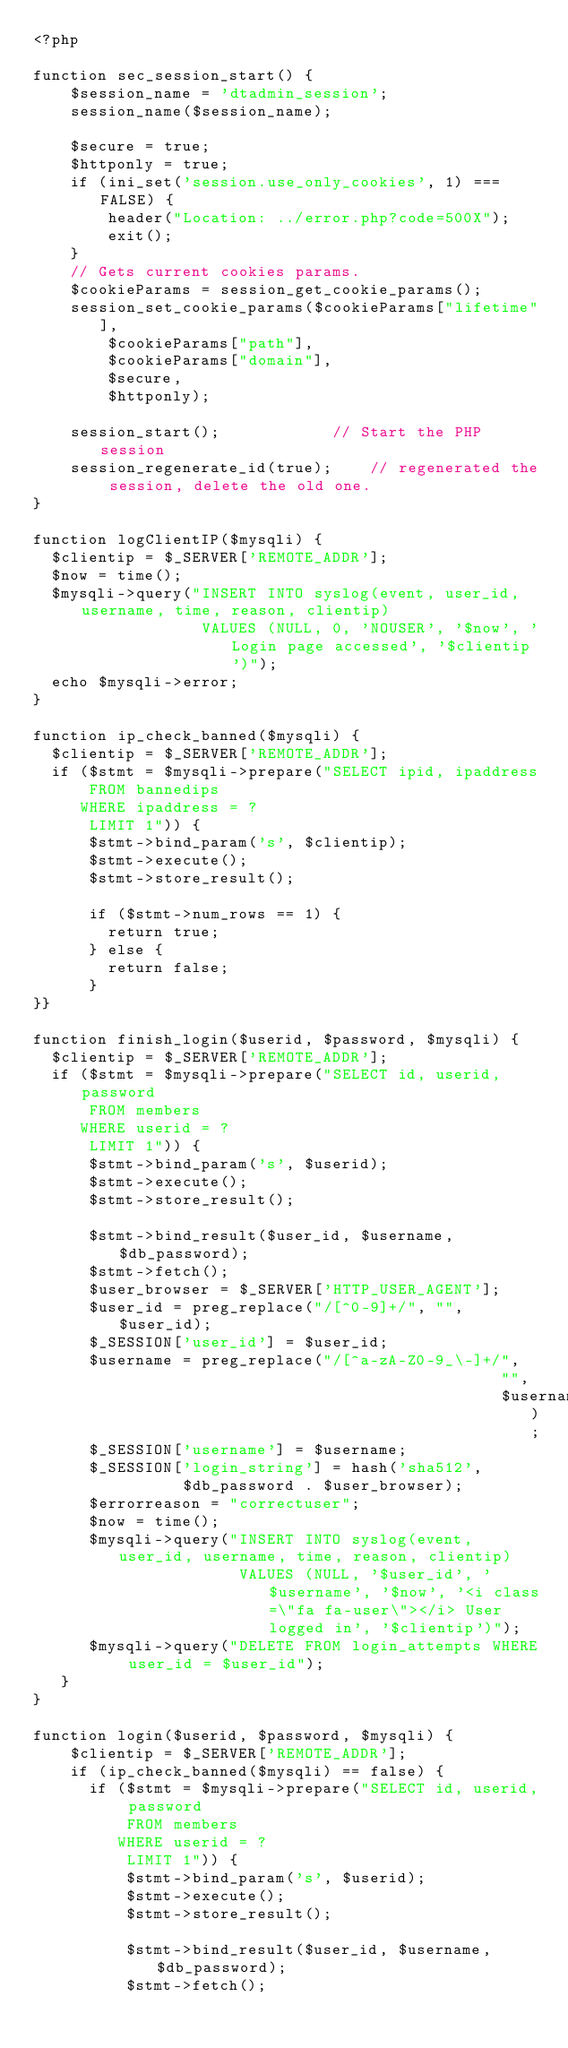<code> <loc_0><loc_0><loc_500><loc_500><_PHP_><?php

function sec_session_start() {
    $session_name = 'dtadmin_session';
    session_name($session_name);

    $secure = true;
    $httponly = true;
    if (ini_set('session.use_only_cookies', 1) === FALSE) {
        header("Location: ../error.php?code=500X");
        exit();
    }
    // Gets current cookies params.
    $cookieParams = session_get_cookie_params();
    session_set_cookie_params($cookieParams["lifetime"],
        $cookieParams["path"],
        $cookieParams["domain"],
        $secure,
        $httponly);

    session_start();            // Start the PHP session
    session_regenerate_id(true);    // regenerated the session, delete the old one.
}

function logClientIP($mysqli) {
  $clientip = $_SERVER['REMOTE_ADDR'];
  $now = time();
  $mysqli->query("INSERT INTO syslog(event, user_id, username, time, reason, clientip)
                  VALUES (NULL, 0, 'NOUSER', '$now', 'Login page accessed', '$clientip')");
  echo $mysqli->error;
}

function ip_check_banned($mysqli) {
  $clientip = $_SERVER['REMOTE_ADDR'];
  if ($stmt = $mysqli->prepare("SELECT ipid, ipaddress
      FROM bannedips
     WHERE ipaddress = ?
      LIMIT 1")) {
      $stmt->bind_param('s', $clientip);
      $stmt->execute();
      $stmt->store_result();

      if ($stmt->num_rows == 1) {
        return true;
      } else {
        return false;
      }
}}

function finish_login($userid, $password, $mysqli) {
  $clientip = $_SERVER['REMOTE_ADDR'];
  if ($stmt = $mysqli->prepare("SELECT id, userid, password
      FROM members
     WHERE userid = ?
      LIMIT 1")) {
      $stmt->bind_param('s', $userid);
      $stmt->execute();
      $stmt->store_result();

      $stmt->bind_result($user_id, $username, $db_password);
      $stmt->fetch();
      $user_browser = $_SERVER['HTTP_USER_AGENT'];
      $user_id = preg_replace("/[^0-9]+/", "", $user_id);
      $_SESSION['user_id'] = $user_id;
      $username = preg_replace("/[^a-zA-Z0-9_\-]+/",
                                                  "",
                                                  $username);
      $_SESSION['username'] = $username;
      $_SESSION['login_string'] = hash('sha512',
                $db_password . $user_browser);
      $errorreason = "correctuser";
      $now = time();
      $mysqli->query("INSERT INTO syslog(event, user_id, username, time, reason, clientip)
                      VALUES (NULL, '$user_id', '$username', '$now', '<i class=\"fa fa-user\"></i> User logged in', '$clientip')");
      $mysqli->query("DELETE FROM login_attempts WHERE user_id = $user_id");
   }
}

function login($userid, $password, $mysqli) {
    $clientip = $_SERVER['REMOTE_ADDR'];
    if (ip_check_banned($mysqli) == false) {
      if ($stmt = $mysqli->prepare("SELECT id, userid, password
          FROM members
         WHERE userid = ?
          LIMIT 1")) {
          $stmt->bind_param('s', $userid);
          $stmt->execute();
          $stmt->store_result();

          $stmt->bind_result($user_id, $username, $db_password);
          $stmt->fetch();
</code> 